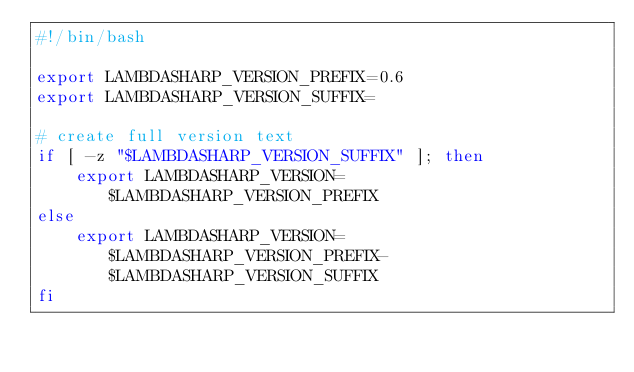Convert code to text. <code><loc_0><loc_0><loc_500><loc_500><_Bash_>#!/bin/bash

export LAMBDASHARP_VERSION_PREFIX=0.6
export LAMBDASHARP_VERSION_SUFFIX=

# create full version text
if [ -z "$LAMBDASHARP_VERSION_SUFFIX" ]; then
    export LAMBDASHARP_VERSION=$LAMBDASHARP_VERSION_PREFIX
else
    export LAMBDASHARP_VERSION=$LAMBDASHARP_VERSION_PREFIX-$LAMBDASHARP_VERSION_SUFFIX
fi
</code> 